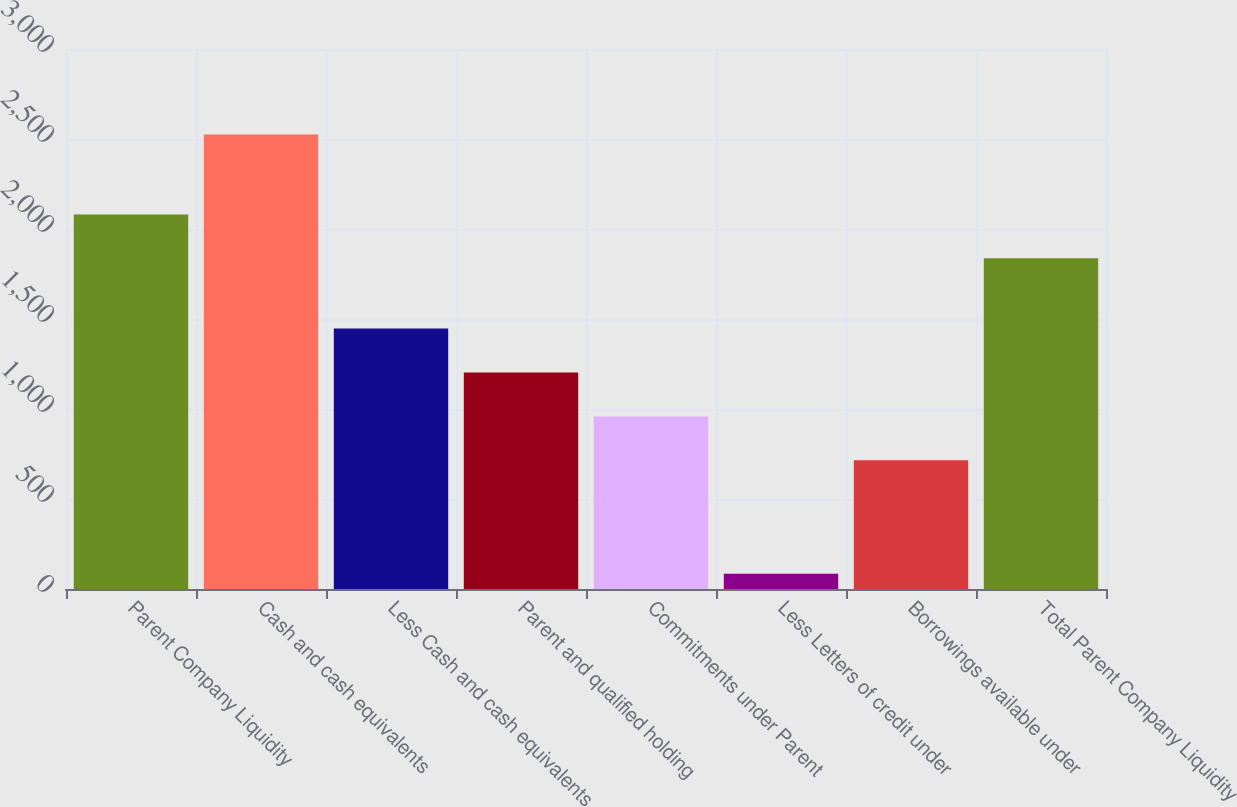<chart> <loc_0><loc_0><loc_500><loc_500><bar_chart><fcel>Parent Company Liquidity<fcel>Cash and cash equivalents<fcel>Less Cash and cash equivalents<fcel>Parent and qualified holding<fcel>Commitments under Parent<fcel>Less Letters of credit under<fcel>Borrowings available under<fcel>Total Parent Company Liquidity<nl><fcel>2081<fcel>2525<fcel>1447<fcel>1203<fcel>959<fcel>85<fcel>715<fcel>1837<nl></chart> 